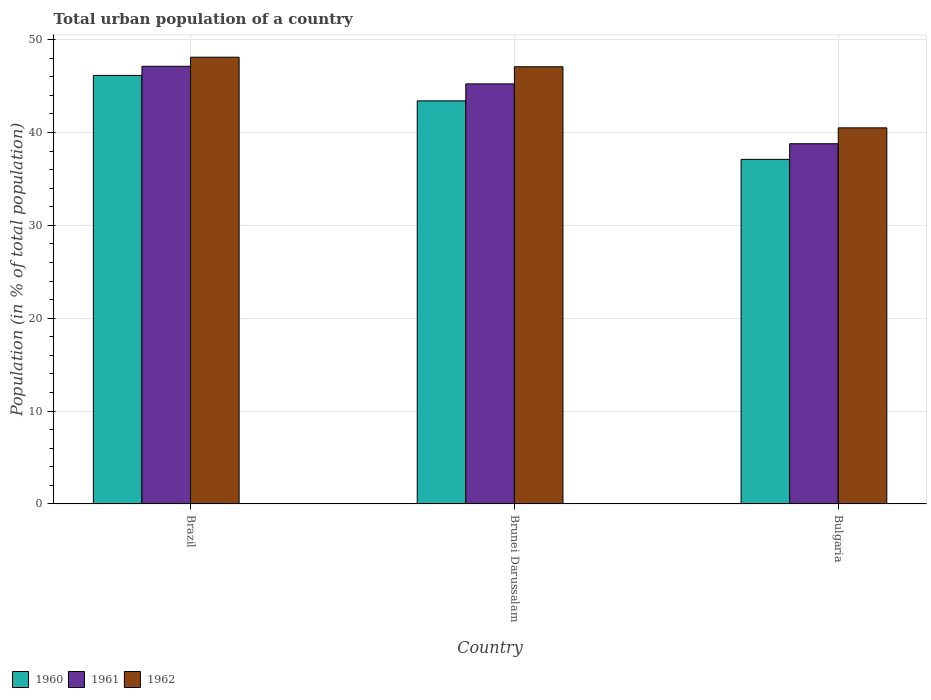Are the number of bars per tick equal to the number of legend labels?
Your answer should be very brief. Yes. How many bars are there on the 3rd tick from the right?
Make the answer very short. 3. What is the label of the 1st group of bars from the left?
Keep it short and to the point. Brazil. In how many cases, is the number of bars for a given country not equal to the number of legend labels?
Your answer should be very brief. 0. What is the urban population in 1961 in Brazil?
Offer a very short reply. 47.12. Across all countries, what is the maximum urban population in 1960?
Ensure brevity in your answer.  46.14. Across all countries, what is the minimum urban population in 1961?
Your response must be concise. 38.78. In which country was the urban population in 1962 maximum?
Provide a short and direct response. Brazil. In which country was the urban population in 1960 minimum?
Your response must be concise. Bulgaria. What is the total urban population in 1962 in the graph?
Ensure brevity in your answer.  135.66. What is the difference between the urban population in 1961 in Brazil and that in Brunei Darussalam?
Ensure brevity in your answer.  1.89. What is the difference between the urban population in 1960 in Bulgaria and the urban population in 1962 in Brazil?
Your answer should be very brief. -11. What is the average urban population in 1962 per country?
Your response must be concise. 45.22. What is the difference between the urban population of/in 1961 and urban population of/in 1960 in Brazil?
Make the answer very short. 0.98. In how many countries, is the urban population in 1960 greater than 26 %?
Provide a short and direct response. 3. What is the ratio of the urban population in 1960 in Brazil to that in Brunei Darussalam?
Make the answer very short. 1.06. Is the difference between the urban population in 1961 in Brazil and Brunei Darussalam greater than the difference between the urban population in 1960 in Brazil and Brunei Darussalam?
Your answer should be compact. No. What is the difference between the highest and the second highest urban population in 1960?
Keep it short and to the point. 6.3. What is the difference between the highest and the lowest urban population in 1960?
Provide a short and direct response. 9.04. In how many countries, is the urban population in 1960 greater than the average urban population in 1960 taken over all countries?
Keep it short and to the point. 2. What does the 1st bar from the right in Brunei Darussalam represents?
Give a very brief answer. 1962. Is it the case that in every country, the sum of the urban population in 1962 and urban population in 1960 is greater than the urban population in 1961?
Make the answer very short. Yes. Are all the bars in the graph horizontal?
Offer a terse response. No. How many countries are there in the graph?
Provide a succinct answer. 3. What is the difference between two consecutive major ticks on the Y-axis?
Keep it short and to the point. 10. Are the values on the major ticks of Y-axis written in scientific E-notation?
Offer a terse response. No. Does the graph contain any zero values?
Your answer should be compact. No. How many legend labels are there?
Keep it short and to the point. 3. How are the legend labels stacked?
Offer a terse response. Horizontal. What is the title of the graph?
Ensure brevity in your answer.  Total urban population of a country. What is the label or title of the X-axis?
Provide a succinct answer. Country. What is the label or title of the Y-axis?
Your answer should be very brief. Population (in % of total population). What is the Population (in % of total population) in 1960 in Brazil?
Ensure brevity in your answer.  46.14. What is the Population (in % of total population) in 1961 in Brazil?
Offer a terse response. 47.12. What is the Population (in % of total population) of 1962 in Brazil?
Your response must be concise. 48.1. What is the Population (in % of total population) in 1960 in Brunei Darussalam?
Your answer should be compact. 43.4. What is the Population (in % of total population) of 1961 in Brunei Darussalam?
Provide a succinct answer. 45.23. What is the Population (in % of total population) of 1962 in Brunei Darussalam?
Provide a short and direct response. 47.07. What is the Population (in % of total population) of 1960 in Bulgaria?
Ensure brevity in your answer.  37.1. What is the Population (in % of total population) in 1961 in Bulgaria?
Your answer should be very brief. 38.78. What is the Population (in % of total population) of 1962 in Bulgaria?
Your answer should be very brief. 40.49. Across all countries, what is the maximum Population (in % of total population) of 1960?
Provide a short and direct response. 46.14. Across all countries, what is the maximum Population (in % of total population) of 1961?
Make the answer very short. 47.12. Across all countries, what is the maximum Population (in % of total population) in 1962?
Provide a short and direct response. 48.1. Across all countries, what is the minimum Population (in % of total population) in 1960?
Provide a short and direct response. 37.1. Across all countries, what is the minimum Population (in % of total population) of 1961?
Your response must be concise. 38.78. Across all countries, what is the minimum Population (in % of total population) of 1962?
Your response must be concise. 40.49. What is the total Population (in % of total population) of 1960 in the graph?
Keep it short and to the point. 126.64. What is the total Population (in % of total population) in 1961 in the graph?
Make the answer very short. 131.13. What is the total Population (in % of total population) of 1962 in the graph?
Provide a short and direct response. 135.66. What is the difference between the Population (in % of total population) of 1960 in Brazil and that in Brunei Darussalam?
Make the answer very short. 2.74. What is the difference between the Population (in % of total population) in 1961 in Brazil and that in Brunei Darussalam?
Offer a very short reply. 1.89. What is the difference between the Population (in % of total population) of 1962 in Brazil and that in Brunei Darussalam?
Offer a very short reply. 1.03. What is the difference between the Population (in % of total population) of 1960 in Brazil and that in Bulgaria?
Your answer should be very brief. 9.04. What is the difference between the Population (in % of total population) in 1961 in Brazil and that in Bulgaria?
Give a very brief answer. 8.34. What is the difference between the Population (in % of total population) of 1962 in Brazil and that in Bulgaria?
Offer a terse response. 7.61. What is the difference between the Population (in % of total population) in 1960 in Brunei Darussalam and that in Bulgaria?
Provide a succinct answer. 6.3. What is the difference between the Population (in % of total population) of 1961 in Brunei Darussalam and that in Bulgaria?
Provide a short and direct response. 6.45. What is the difference between the Population (in % of total population) of 1962 in Brunei Darussalam and that in Bulgaria?
Give a very brief answer. 6.58. What is the difference between the Population (in % of total population) in 1960 in Brazil and the Population (in % of total population) in 1961 in Brunei Darussalam?
Give a very brief answer. 0.91. What is the difference between the Population (in % of total population) of 1960 in Brazil and the Population (in % of total population) of 1962 in Brunei Darussalam?
Keep it short and to the point. -0.93. What is the difference between the Population (in % of total population) of 1961 in Brazil and the Population (in % of total population) of 1962 in Brunei Darussalam?
Make the answer very short. 0.05. What is the difference between the Population (in % of total population) of 1960 in Brazil and the Population (in % of total population) of 1961 in Bulgaria?
Offer a very short reply. 7.36. What is the difference between the Population (in % of total population) in 1960 in Brazil and the Population (in % of total population) in 1962 in Bulgaria?
Your response must be concise. 5.64. What is the difference between the Population (in % of total population) of 1961 in Brazil and the Population (in % of total population) of 1962 in Bulgaria?
Your answer should be very brief. 6.63. What is the difference between the Population (in % of total population) in 1960 in Brunei Darussalam and the Population (in % of total population) in 1961 in Bulgaria?
Make the answer very short. 4.62. What is the difference between the Population (in % of total population) in 1960 in Brunei Darussalam and the Population (in % of total population) in 1962 in Bulgaria?
Provide a succinct answer. 2.91. What is the difference between the Population (in % of total population) in 1961 in Brunei Darussalam and the Population (in % of total population) in 1962 in Bulgaria?
Offer a very short reply. 4.73. What is the average Population (in % of total population) in 1960 per country?
Give a very brief answer. 42.21. What is the average Population (in % of total population) in 1961 per country?
Your answer should be very brief. 43.71. What is the average Population (in % of total population) of 1962 per country?
Make the answer very short. 45.22. What is the difference between the Population (in % of total population) of 1960 and Population (in % of total population) of 1961 in Brazil?
Your response must be concise. -0.98. What is the difference between the Population (in % of total population) in 1960 and Population (in % of total population) in 1962 in Brazil?
Give a very brief answer. -1.96. What is the difference between the Population (in % of total population) in 1961 and Population (in % of total population) in 1962 in Brazil?
Your response must be concise. -0.98. What is the difference between the Population (in % of total population) of 1960 and Population (in % of total population) of 1961 in Brunei Darussalam?
Your answer should be compact. -1.83. What is the difference between the Population (in % of total population) in 1960 and Population (in % of total population) in 1962 in Brunei Darussalam?
Provide a short and direct response. -3.67. What is the difference between the Population (in % of total population) in 1961 and Population (in % of total population) in 1962 in Brunei Darussalam?
Your response must be concise. -1.84. What is the difference between the Population (in % of total population) in 1960 and Population (in % of total population) in 1961 in Bulgaria?
Give a very brief answer. -1.68. What is the difference between the Population (in % of total population) of 1960 and Population (in % of total population) of 1962 in Bulgaria?
Offer a terse response. -3.39. What is the difference between the Population (in % of total population) in 1961 and Population (in % of total population) in 1962 in Bulgaria?
Your response must be concise. -1.71. What is the ratio of the Population (in % of total population) in 1960 in Brazil to that in Brunei Darussalam?
Provide a succinct answer. 1.06. What is the ratio of the Population (in % of total population) of 1961 in Brazil to that in Brunei Darussalam?
Ensure brevity in your answer.  1.04. What is the ratio of the Population (in % of total population) in 1962 in Brazil to that in Brunei Darussalam?
Your response must be concise. 1.02. What is the ratio of the Population (in % of total population) of 1960 in Brazil to that in Bulgaria?
Your response must be concise. 1.24. What is the ratio of the Population (in % of total population) in 1961 in Brazil to that in Bulgaria?
Provide a short and direct response. 1.22. What is the ratio of the Population (in % of total population) in 1962 in Brazil to that in Bulgaria?
Provide a short and direct response. 1.19. What is the ratio of the Population (in % of total population) in 1960 in Brunei Darussalam to that in Bulgaria?
Ensure brevity in your answer.  1.17. What is the ratio of the Population (in % of total population) of 1961 in Brunei Darussalam to that in Bulgaria?
Offer a very short reply. 1.17. What is the ratio of the Population (in % of total population) of 1962 in Brunei Darussalam to that in Bulgaria?
Make the answer very short. 1.16. What is the difference between the highest and the second highest Population (in % of total population) of 1960?
Your answer should be compact. 2.74. What is the difference between the highest and the second highest Population (in % of total population) of 1961?
Provide a succinct answer. 1.89. What is the difference between the highest and the lowest Population (in % of total population) of 1960?
Provide a succinct answer. 9.04. What is the difference between the highest and the lowest Population (in % of total population) of 1961?
Provide a succinct answer. 8.34. What is the difference between the highest and the lowest Population (in % of total population) in 1962?
Ensure brevity in your answer.  7.61. 